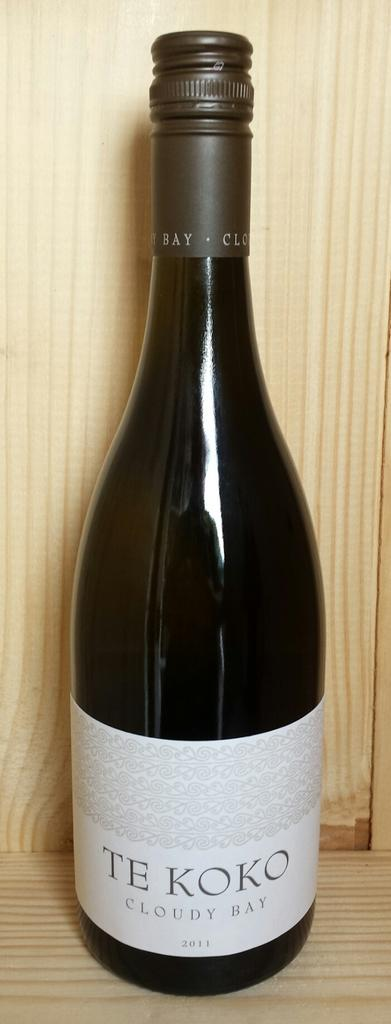<image>
Share a concise interpretation of the image provided. A bottle of 2011 Te Koko wine is on a wooden shelf for a display. 